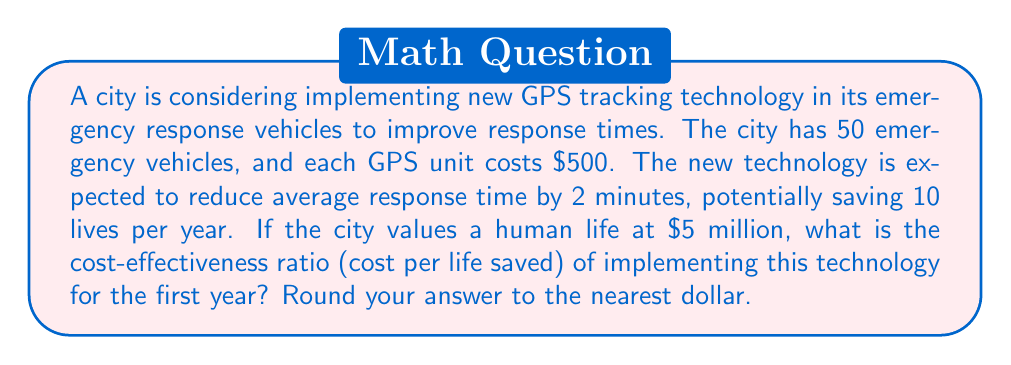Can you answer this question? Let's break this problem down step-by-step:

1. Calculate the total cost of implementation:
   Number of vehicles = 50
   Cost per GPS unit = $500
   Total cost = $500 × 50 = $25,000

2. Calculate the benefit:
   Lives saved per year = 10
   Value of a human life = $5,000,000
   Total benefit = 10 × $5,000,000 = $50,000,000

3. Calculate the cost-effectiveness ratio:
   Cost-effectiveness ratio = Cost / Lives saved

   $$\text{Cost-effectiveness ratio} = \frac{\text{Total cost}}{\text{Lives saved}}$$

   $$= \frac{$25,000}{10}$$

   $$= $2,500 \text{ per life saved}$$

This means that for every life saved, the city is spending $2,500 on the GPS technology.

4. To put this in perspective, we can compare it to the value of a human life:
   
   $$\text{Return on investment} = \frac{\text{Value of a life}}{\text{Cost per life saved}}$$

   $$= \frac{$5,000,000}{$2,500} = 2000$$

This indicates that for every dollar spent on the GPS technology, the city is getting $2,000 worth of value in terms of lives saved.
Answer: $2,500 per life saved 